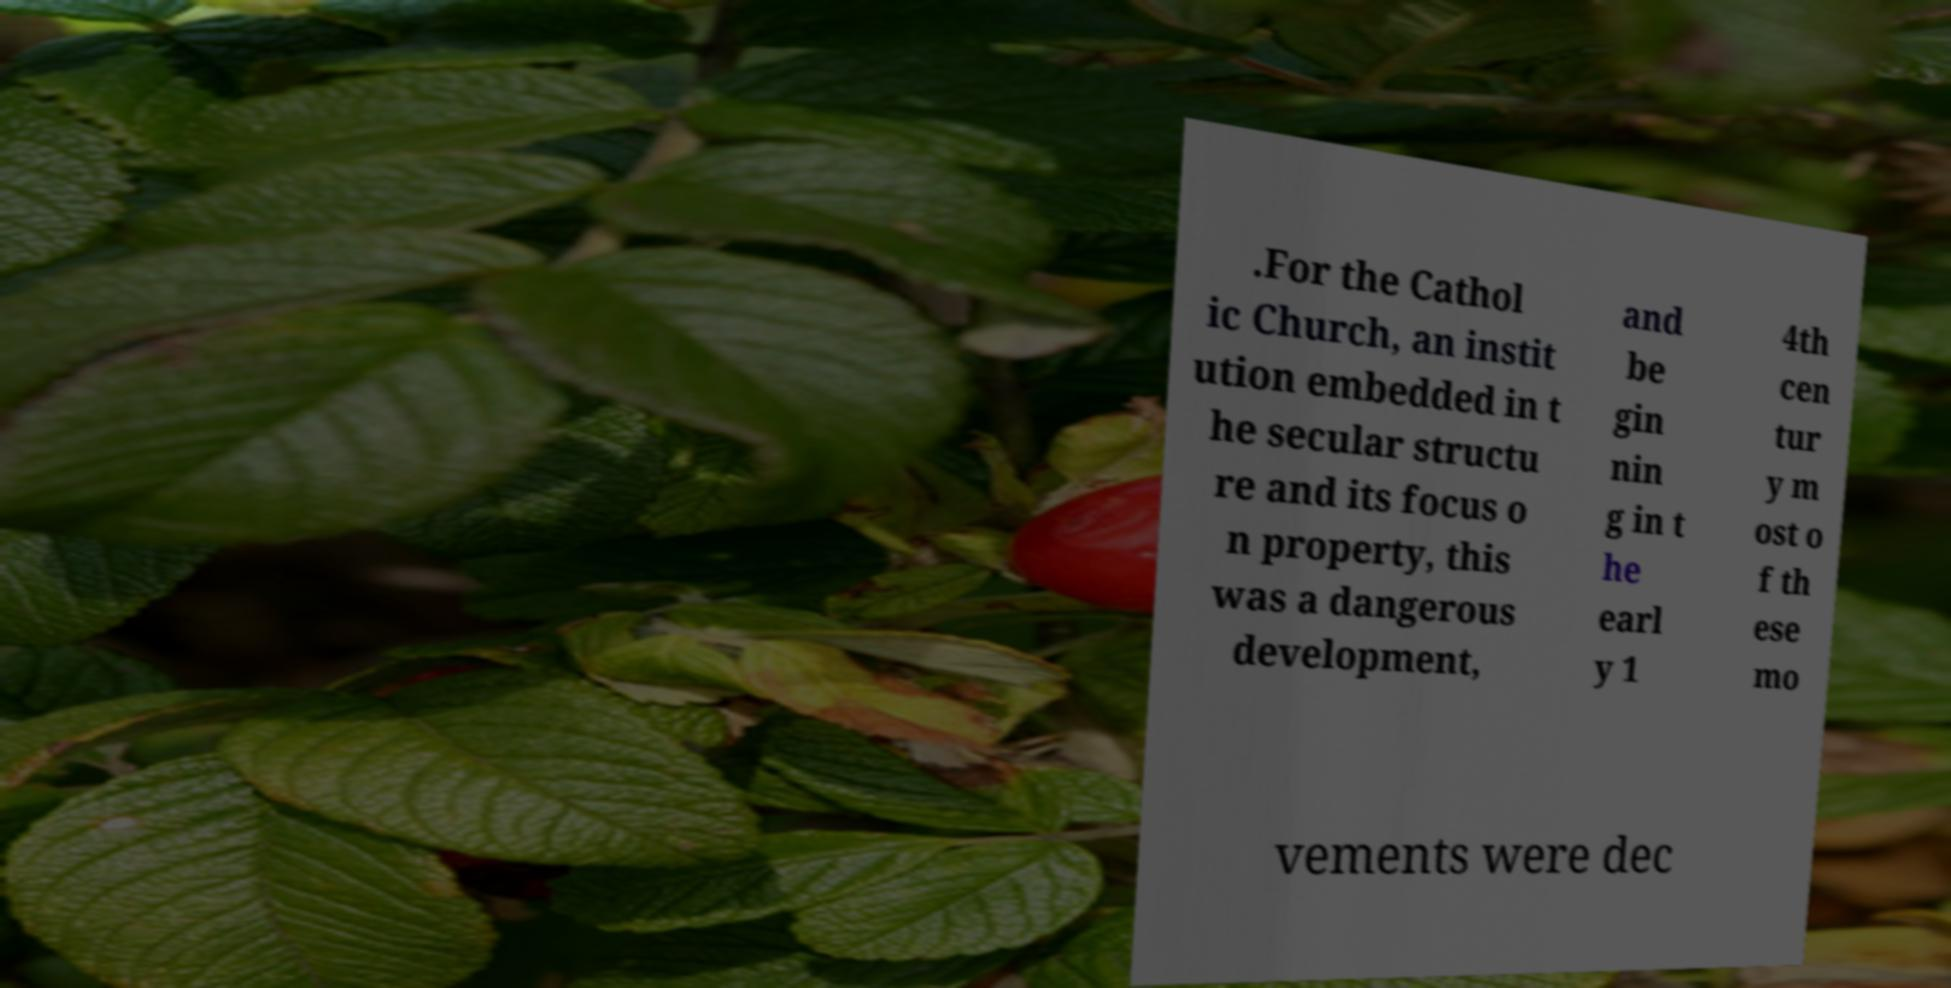For documentation purposes, I need the text within this image transcribed. Could you provide that? .For the Cathol ic Church, an instit ution embedded in t he secular structu re and its focus o n property, this was a dangerous development, and be gin nin g in t he earl y 1 4th cen tur y m ost o f th ese mo vements were dec 